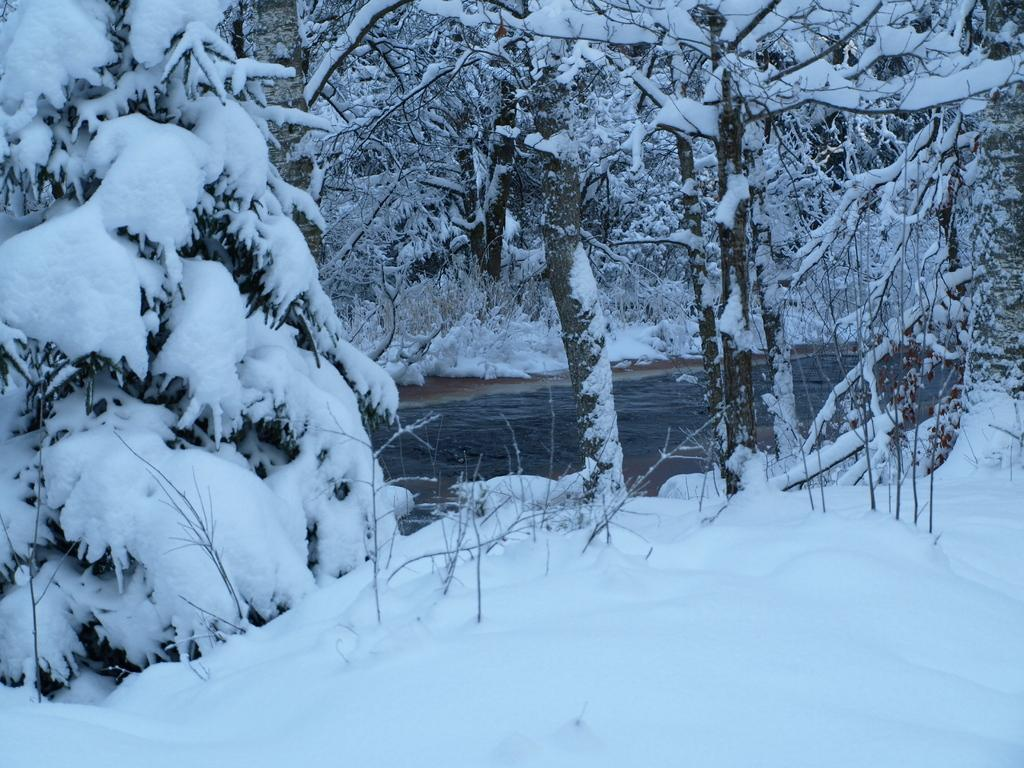What type of weather is suggested by the presence of snow in the image? The presence of snow on the trees and ground suggests cold weather. What is the natural element visible in the image? Water is visible in the image. Can you describe the condition of the trees in the image? The trees have snow on them in the image. How many cherries can be seen hanging from the trees in the image? There are no cherries present on the trees in the image. What type of joke is being told by the queen in the image? There is no queen or joke present in the image. 